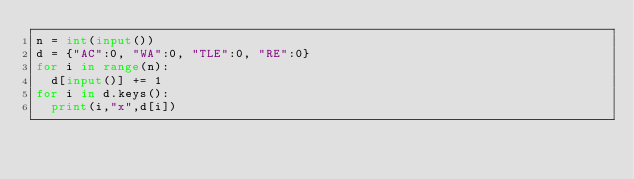<code> <loc_0><loc_0><loc_500><loc_500><_Python_>n = int(input())
d = {"AC":0, "WA":0, "TLE":0, "RE":0}
for i in range(n):
  d[input()] += 1
for i in d.keys():
  print(i,"x",d[i])</code> 